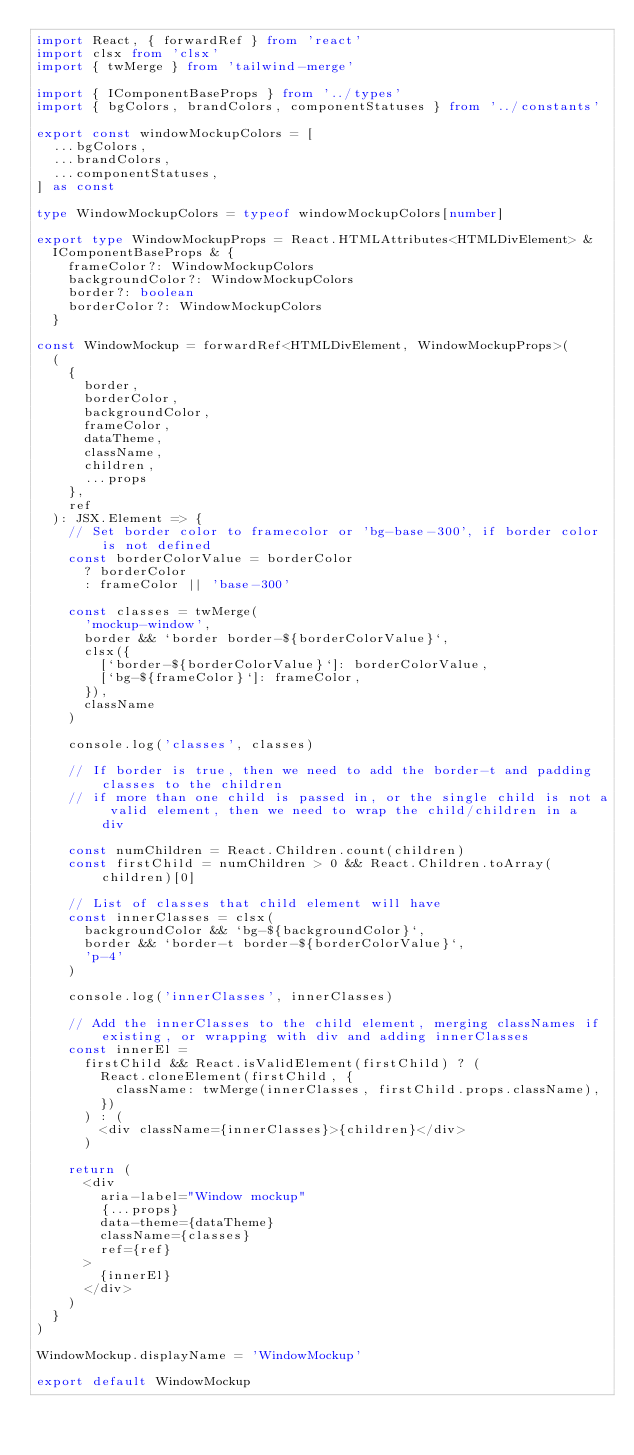<code> <loc_0><loc_0><loc_500><loc_500><_TypeScript_>import React, { forwardRef } from 'react'
import clsx from 'clsx'
import { twMerge } from 'tailwind-merge'

import { IComponentBaseProps } from '../types'
import { bgColors, brandColors, componentStatuses } from '../constants'

export const windowMockupColors = [
  ...bgColors,
  ...brandColors,
  ...componentStatuses,
] as const

type WindowMockupColors = typeof windowMockupColors[number]

export type WindowMockupProps = React.HTMLAttributes<HTMLDivElement> &
  IComponentBaseProps & {
    frameColor?: WindowMockupColors
    backgroundColor?: WindowMockupColors
    border?: boolean
    borderColor?: WindowMockupColors
  }

const WindowMockup = forwardRef<HTMLDivElement, WindowMockupProps>(
  (
    {
      border,
      borderColor,
      backgroundColor,
      frameColor,
      dataTheme,
      className,
      children,
      ...props
    },
    ref
  ): JSX.Element => {
    // Set border color to framecolor or 'bg-base-300', if border color is not defined
    const borderColorValue = borderColor
      ? borderColor
      : frameColor || 'base-300'

    const classes = twMerge(
      'mockup-window',
      border && `border border-${borderColorValue}`,
      clsx({
        [`border-${borderColorValue}`]: borderColorValue,
        [`bg-${frameColor}`]: frameColor,
      }),
      className
    )

    console.log('classes', classes)

    // If border is true, then we need to add the border-t and padding classes to the children
    // if more than one child is passed in, or the single child is not a valid element, then we need to wrap the child/children in a div

    const numChildren = React.Children.count(children)
    const firstChild = numChildren > 0 && React.Children.toArray(children)[0]

    // List of classes that child element will have
    const innerClasses = clsx(
      backgroundColor && `bg-${backgroundColor}`,
      border && `border-t border-${borderColorValue}`,
      'p-4'
    )

    console.log('innerClasses', innerClasses)

    // Add the innerClasses to the child element, merging classNames if existing, or wrapping with div and adding innerClasses
    const innerEl =
      firstChild && React.isValidElement(firstChild) ? (
        React.cloneElement(firstChild, {
          className: twMerge(innerClasses, firstChild.props.className),
        })
      ) : (
        <div className={innerClasses}>{children}</div>
      )

    return (
      <div
        aria-label="Window mockup"
        {...props}
        data-theme={dataTheme}
        className={classes}
        ref={ref}
      >
        {innerEl}
      </div>
    )
  }
)

WindowMockup.displayName = 'WindowMockup'

export default WindowMockup
</code> 